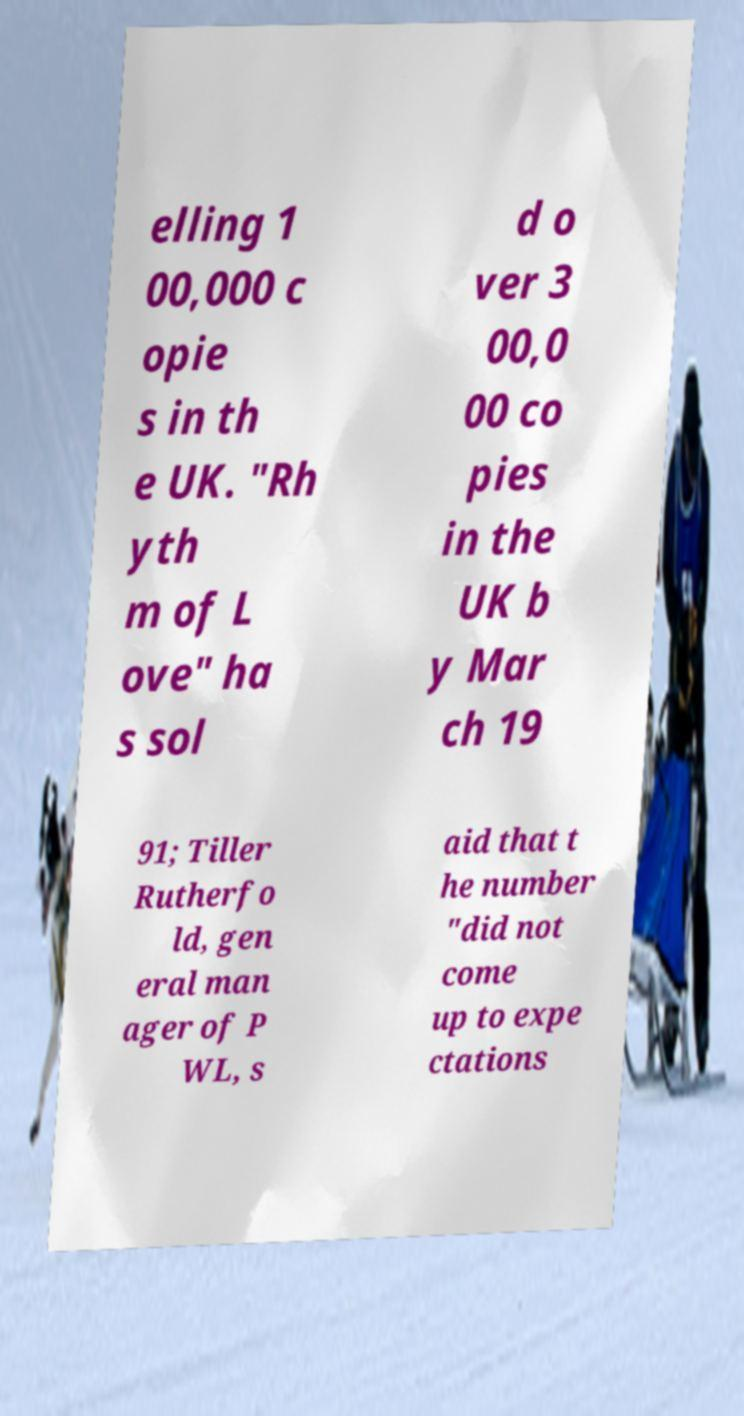I need the written content from this picture converted into text. Can you do that? elling 1 00,000 c opie s in th e UK. "Rh yth m of L ove" ha s sol d o ver 3 00,0 00 co pies in the UK b y Mar ch 19 91; Tiller Rutherfo ld, gen eral man ager of P WL, s aid that t he number "did not come up to expe ctations 